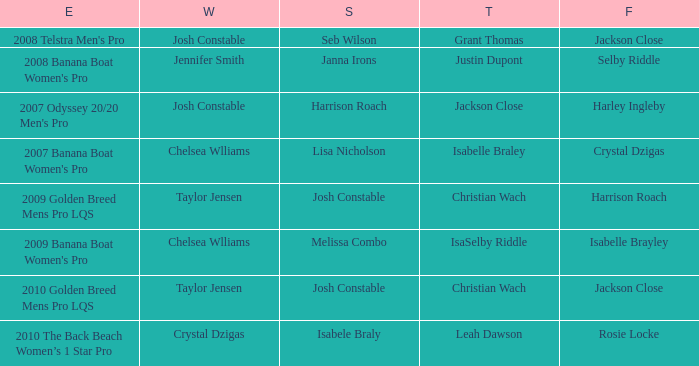Who achieved second position as isabelle brayley ranked fourth? Melissa Combo. Can you give me this table as a dict? {'header': ['E', 'W', 'S', 'T', 'F'], 'rows': [["2008 Telstra Men's Pro", 'Josh Constable', 'Seb Wilson', 'Grant Thomas', 'Jackson Close'], ["2008 Banana Boat Women's Pro", 'Jennifer Smith', 'Janna Irons', 'Justin Dupont', 'Selby Riddle'], ["2007 Odyssey 20/20 Men's Pro", 'Josh Constable', 'Harrison Roach', 'Jackson Close', 'Harley Ingleby'], ["2007 Banana Boat Women's Pro", 'Chelsea Wlliams', 'Lisa Nicholson', 'Isabelle Braley', 'Crystal Dzigas'], ['2009 Golden Breed Mens Pro LQS', 'Taylor Jensen', 'Josh Constable', 'Christian Wach', 'Harrison Roach'], ["2009 Banana Boat Women's Pro", 'Chelsea Wlliams', 'Melissa Combo', 'IsaSelby Riddle', 'Isabelle Brayley'], ['2010 Golden Breed Mens Pro LQS', 'Taylor Jensen', 'Josh Constable', 'Christian Wach', 'Jackson Close'], ['2010 The Back Beach Women’s 1 Star Pro', 'Crystal Dzigas', 'Isabele Braly', 'Leah Dawson', 'Rosie Locke']]} 